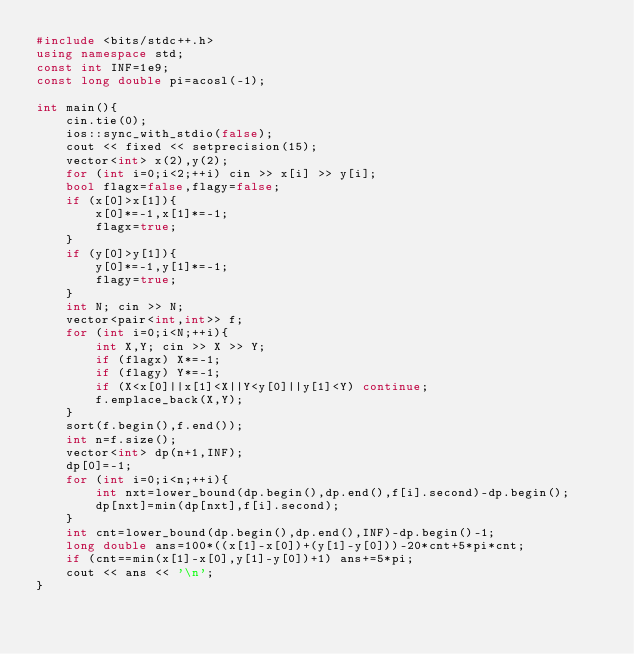<code> <loc_0><loc_0><loc_500><loc_500><_C++_>#include <bits/stdc++.h>
using namespace std;
const int INF=1e9;
const long double pi=acosl(-1);

int main(){
    cin.tie(0);
    ios::sync_with_stdio(false);
    cout << fixed << setprecision(15);
    vector<int> x(2),y(2);
    for (int i=0;i<2;++i) cin >> x[i] >> y[i];
    bool flagx=false,flagy=false;
    if (x[0]>x[1]){
        x[0]*=-1,x[1]*=-1;
        flagx=true;
    }
    if (y[0]>y[1]){
        y[0]*=-1,y[1]*=-1;
        flagy=true;
    }
    int N; cin >> N;
    vector<pair<int,int>> f;
    for (int i=0;i<N;++i){
        int X,Y; cin >> X >> Y;
        if (flagx) X*=-1;
        if (flagy) Y*=-1;
        if (X<x[0]||x[1]<X||Y<y[0]||y[1]<Y) continue;
        f.emplace_back(X,Y);
    }
    sort(f.begin(),f.end());
    int n=f.size();
    vector<int> dp(n+1,INF);
    dp[0]=-1;
    for (int i=0;i<n;++i){
        int nxt=lower_bound(dp.begin(),dp.end(),f[i].second)-dp.begin();
        dp[nxt]=min(dp[nxt],f[i].second);
    }
    int cnt=lower_bound(dp.begin(),dp.end(),INF)-dp.begin()-1;
    long double ans=100*((x[1]-x[0])+(y[1]-y[0]))-20*cnt+5*pi*cnt;
    if (cnt==min(x[1]-x[0],y[1]-y[0])+1) ans+=5*pi;
    cout << ans << '\n';
}</code> 